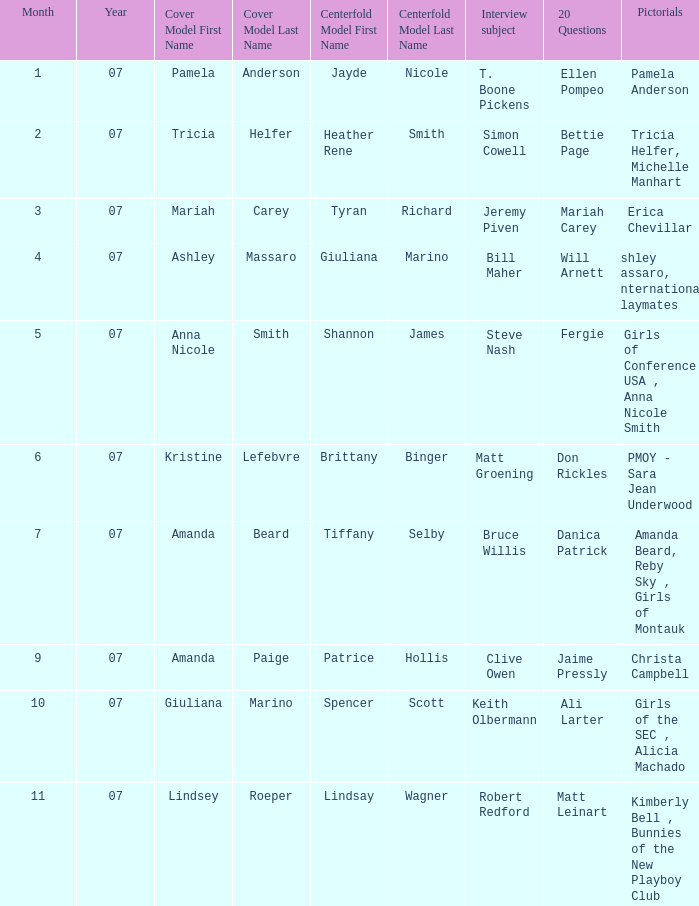Who was the centerfold model when the issue's pictorial was kimberly bell , bunnies of the new playboy club? Lindsay Wagner. 